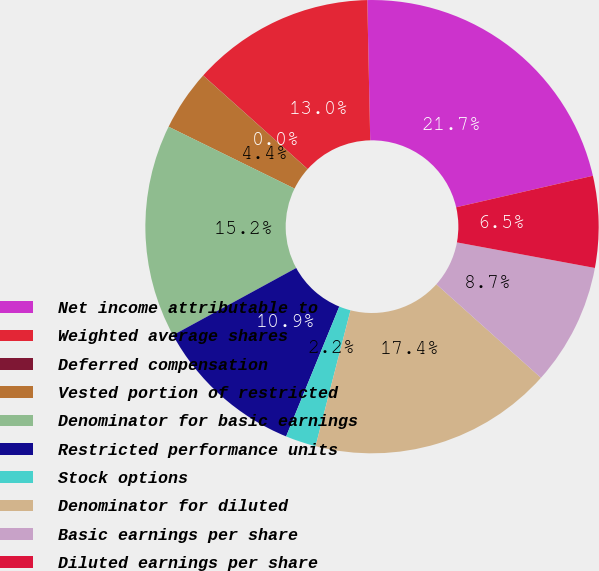Convert chart. <chart><loc_0><loc_0><loc_500><loc_500><pie_chart><fcel>Net income attributable to<fcel>Weighted average shares<fcel>Deferred compensation<fcel>Vested portion of restricted<fcel>Denominator for basic earnings<fcel>Restricted performance units<fcel>Stock options<fcel>Denominator for diluted<fcel>Basic earnings per share<fcel>Diluted earnings per share<nl><fcel>21.73%<fcel>13.04%<fcel>0.01%<fcel>4.35%<fcel>15.21%<fcel>10.87%<fcel>2.18%<fcel>17.39%<fcel>8.7%<fcel>6.52%<nl></chart> 